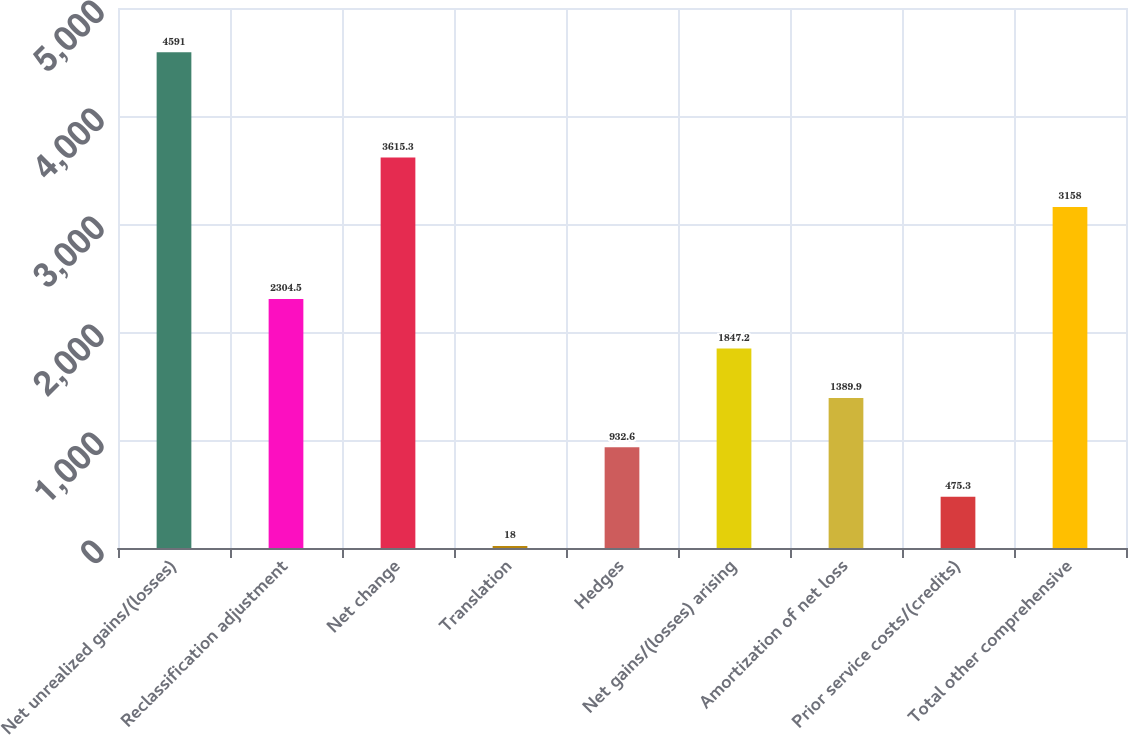Convert chart to OTSL. <chart><loc_0><loc_0><loc_500><loc_500><bar_chart><fcel>Net unrealized gains/(losses)<fcel>Reclassification adjustment<fcel>Net change<fcel>Translation<fcel>Hedges<fcel>Net gains/(losses) arising<fcel>Amortization of net loss<fcel>Prior service costs/(credits)<fcel>Total other comprehensive<nl><fcel>4591<fcel>2304.5<fcel>3615.3<fcel>18<fcel>932.6<fcel>1847.2<fcel>1389.9<fcel>475.3<fcel>3158<nl></chart> 